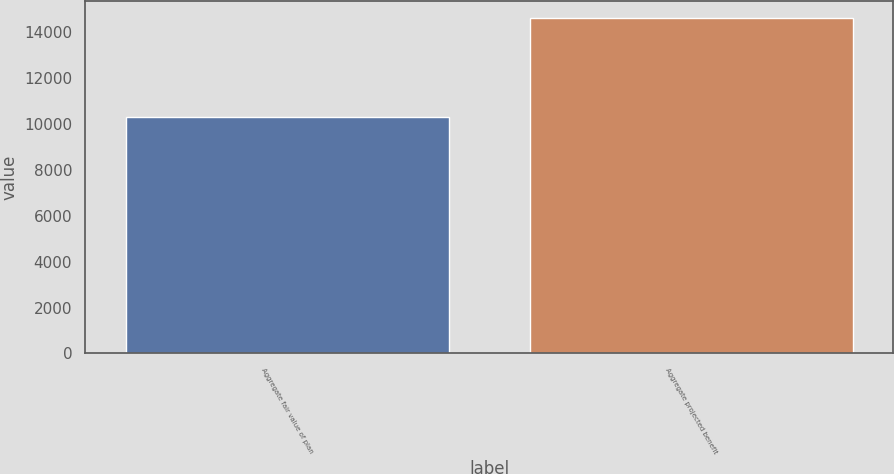Convert chart to OTSL. <chart><loc_0><loc_0><loc_500><loc_500><bar_chart><fcel>Aggregate fair value of plan<fcel>Aggregate projected benefit<nl><fcel>10283<fcel>14618<nl></chart> 